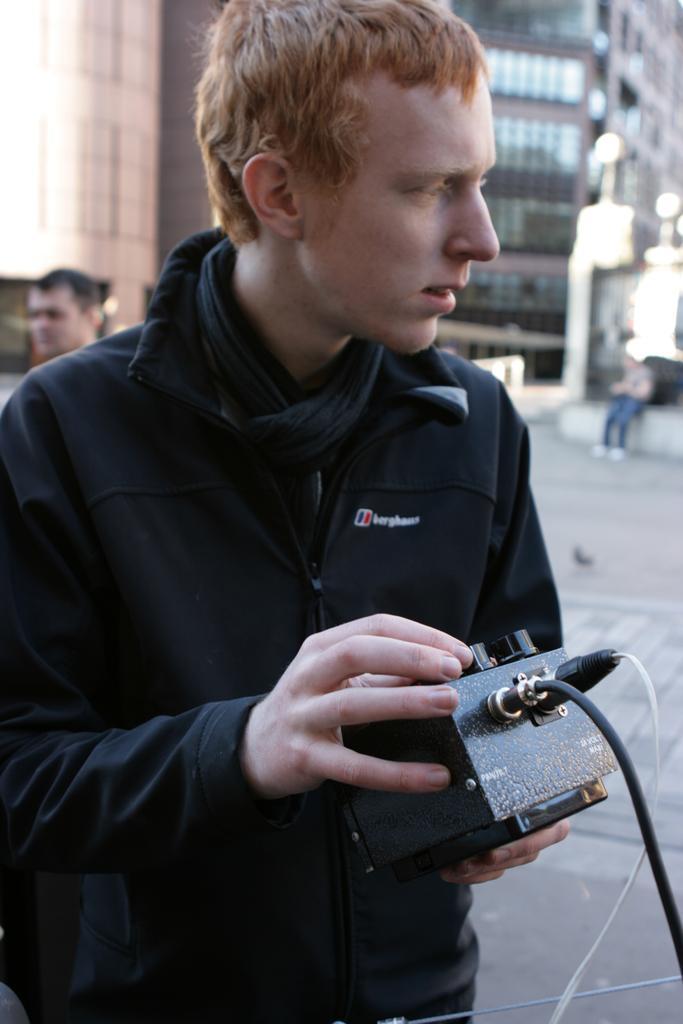Can you describe this image briefly? In this image we can see a person holding a metal operator containing buttons and wires. On the backside we can see a person sitting and a building. 